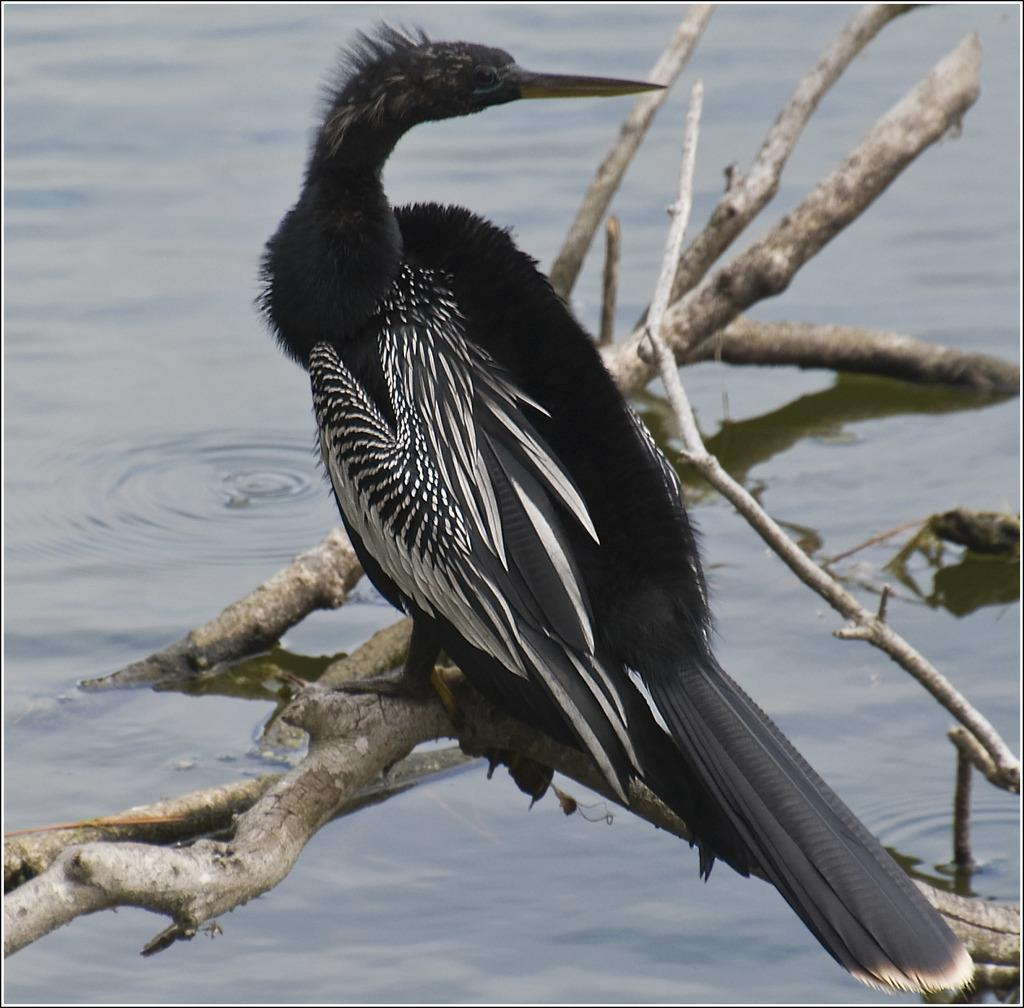What type of animal can be seen in the image? There is a bird in the image. Where is the bird located? The bird is on a stem. What can be seen in the background of the image? There is water visible in the background of the image. What type of badge is the bird wearing in the image? There is no badge present in the image; the bird is simply on a stem. 